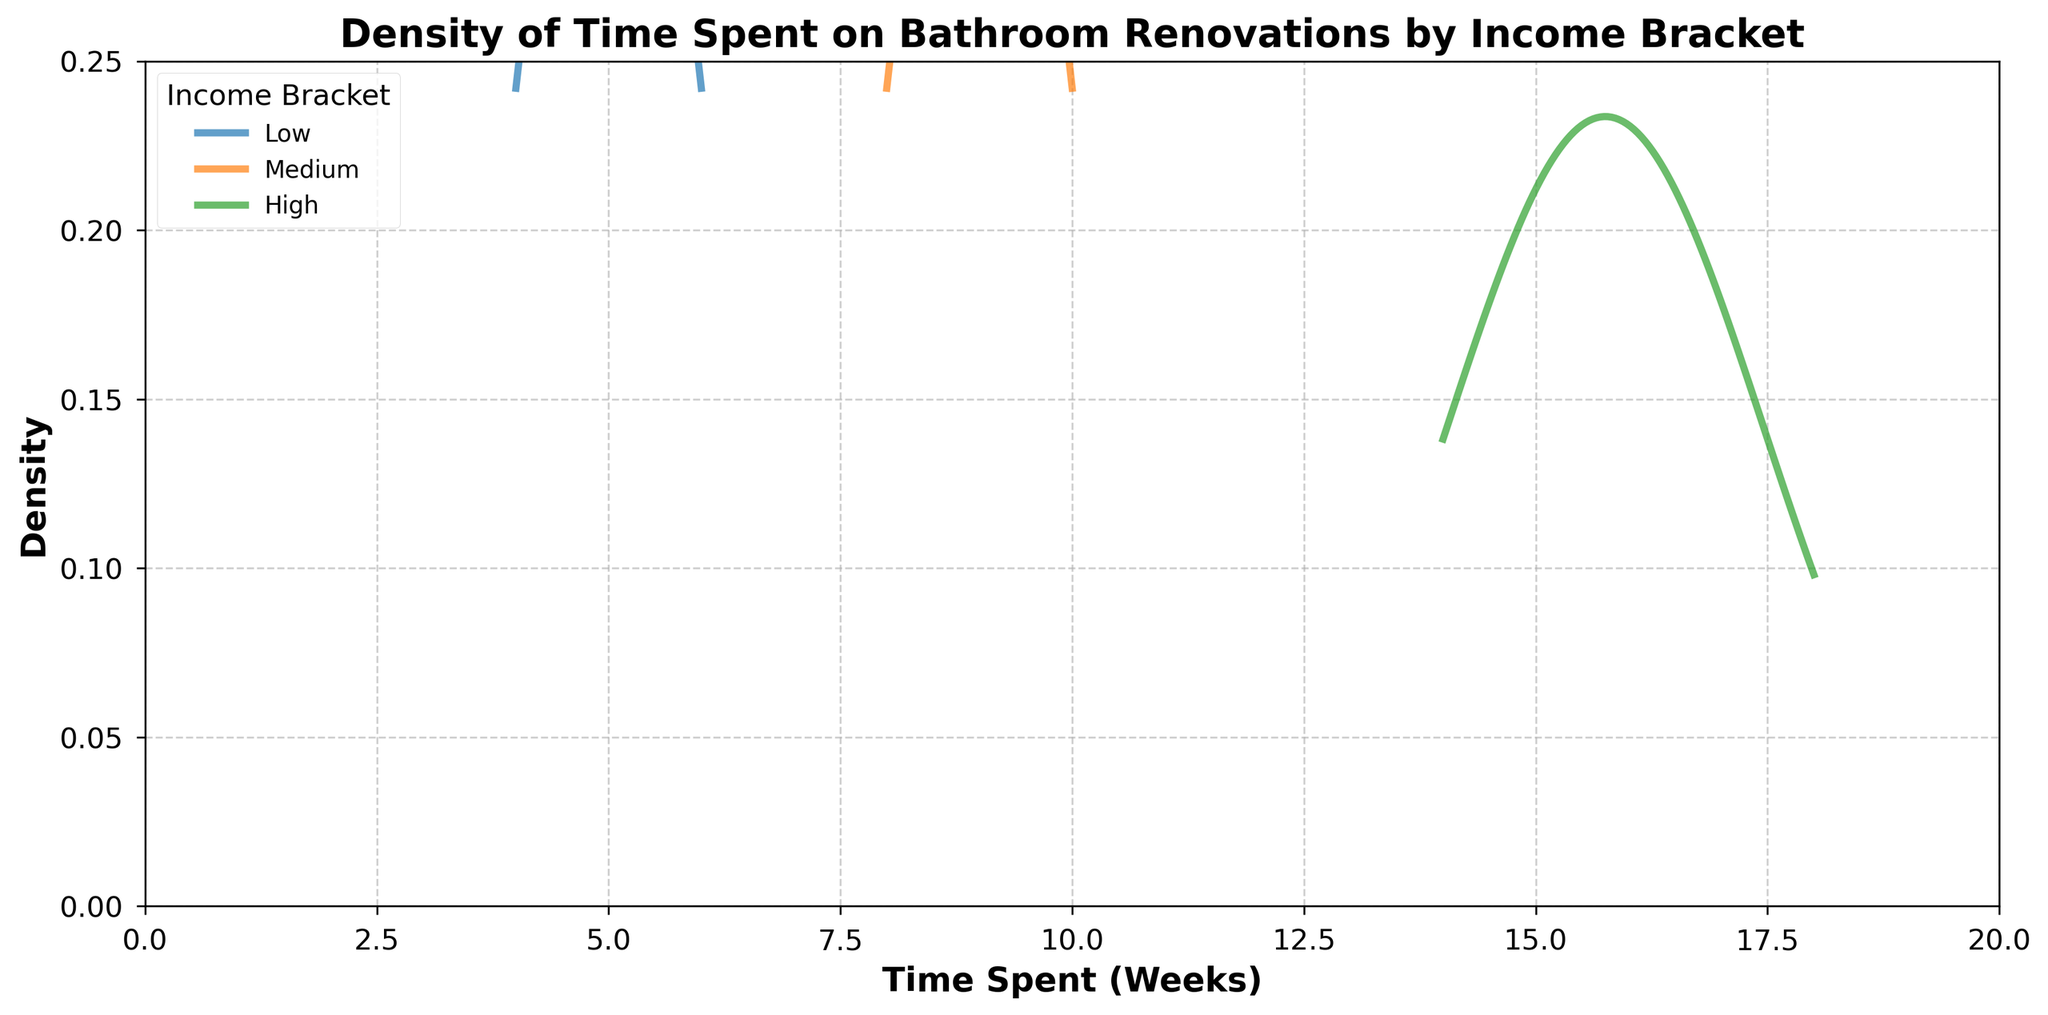What is the title of the figure? The title of the figure is displayed at the top of the plot. It summarizes what the plot represents.
Answer: Density of Time Spent on Bathroom Renovations by Income Bracket What are the labels for the x and y axes? The x-axis label represents the variable corresponding to the horizontal axis, and the y-axis label represents the density, which is shown on the vertical axis.
Answer: x-axis: Time Spent (Weeks), y-axis: Density What is the income bracket with the highest peak density? By observing the highest peak across the income brackets, we can determine which bracket has the highest density at its peak.
Answer: High What is the range of time spent on bathroom renovations for low-income brackets? To find the range, we need to look at the minimum and maximum values on the x-axis for the low-income bracket's density curve.
Answer: 4 to 6 weeks Compare the time spent on bathroom renovations between medium and high-income brackets. Who spends more time on average? By comparing the center of the density curves of medium and high-income brackets, we can determine which density curve is shifted to the right. The one shifted more to the right indicates higher average time spent.
Answer: High Which income bracket has the widest spread in time spent on bathroom renovations? The width of the density curve indicates the spread of the distribution. A wider curve represents a wider spread of time spent.
Answer: High Where is the density curve for the medium-income bracket centered around? The center of the density curve can be estimated by observing where the peak or the average point of the curve is located on the x-axis.
Answer: Around 9 weeks How many income brackets are shown in the figure? By checking the legend or the number of distinct density curves, we can determine the number of income brackets represented.
Answer: Three Does any income bracket have overlapping time spent ranges with another bracket? Which ones? By observing the density curves' overlapping parts, we can determine if any income brackets have similar time spent ranges.
Answer: Medium and High What is the lowest density value observed in the high-income bracket? The lowest density value can be found by observing the lowest point on the density curve for the high-income bracket.
Answer: Close to 0 